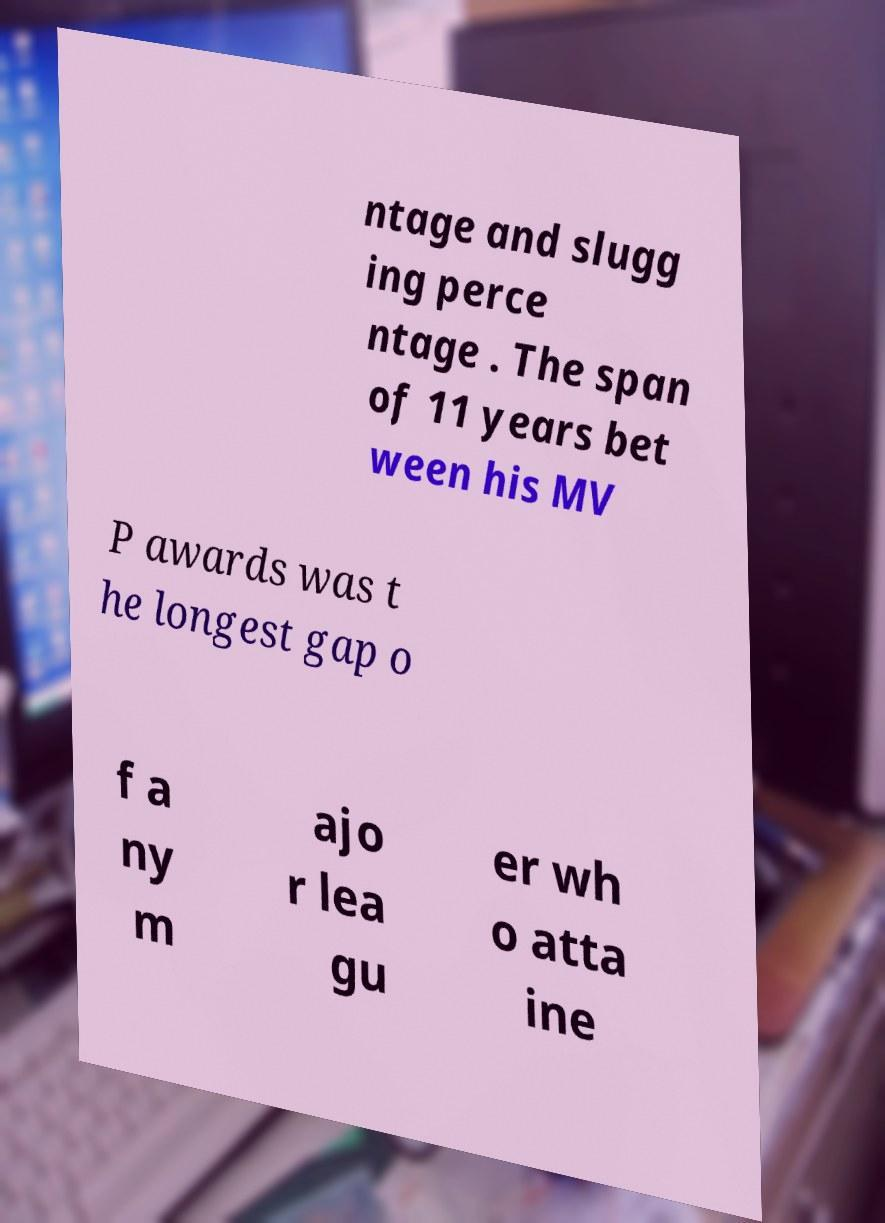For documentation purposes, I need the text within this image transcribed. Could you provide that? ntage and slugg ing perce ntage . The span of 11 years bet ween his MV P awards was t he longest gap o f a ny m ajo r lea gu er wh o atta ine 